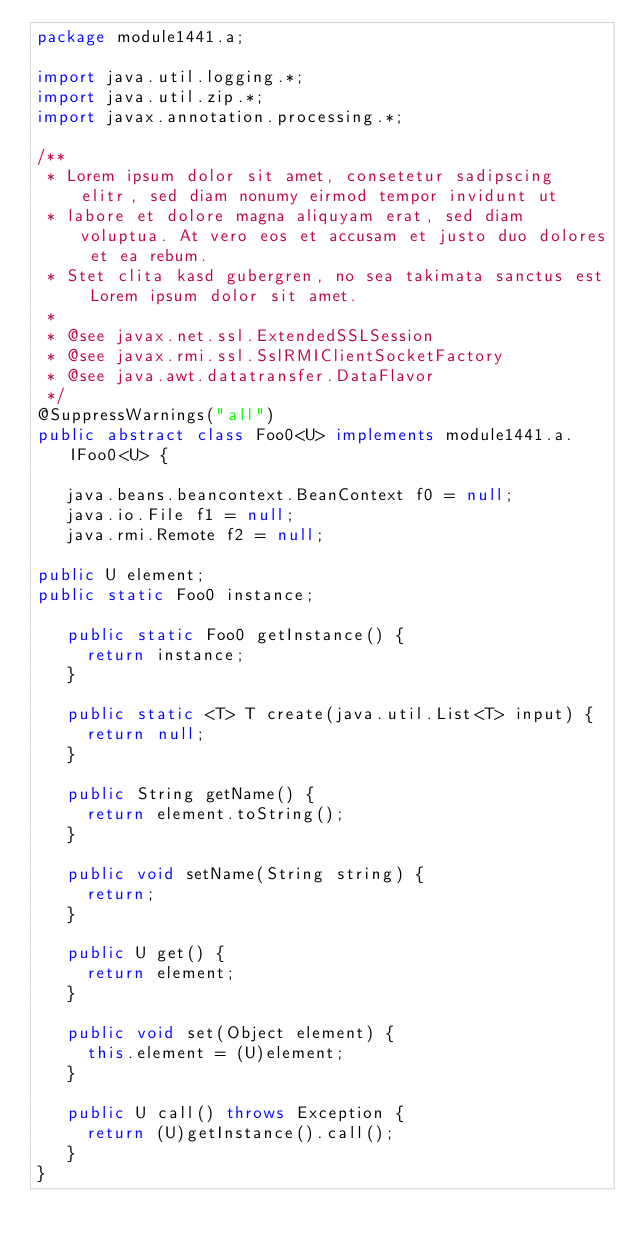Convert code to text. <code><loc_0><loc_0><loc_500><loc_500><_Java_>package module1441.a;

import java.util.logging.*;
import java.util.zip.*;
import javax.annotation.processing.*;

/**
 * Lorem ipsum dolor sit amet, consetetur sadipscing elitr, sed diam nonumy eirmod tempor invidunt ut 
 * labore et dolore magna aliquyam erat, sed diam voluptua. At vero eos et accusam et justo duo dolores et ea rebum. 
 * Stet clita kasd gubergren, no sea takimata sanctus est Lorem ipsum dolor sit amet. 
 *
 * @see javax.net.ssl.ExtendedSSLSession
 * @see javax.rmi.ssl.SslRMIClientSocketFactory
 * @see java.awt.datatransfer.DataFlavor
 */
@SuppressWarnings("all")
public abstract class Foo0<U> implements module1441.a.IFoo0<U> {

	 java.beans.beancontext.BeanContext f0 = null;
	 java.io.File f1 = null;
	 java.rmi.Remote f2 = null;

public U element;
public static Foo0 instance;

	 public static Foo0 getInstance() {
	 	 return instance;
	 }

	 public static <T> T create(java.util.List<T> input) {
	 	 return null;
	 }

	 public String getName() {
	 	 return element.toString();
	 }

	 public void setName(String string) {
	 	 return;
	 }

	 public U get() {
	 	 return element;
	 }

	 public void set(Object element) {
	 	 this.element = (U)element;
	 }

	 public U call() throws Exception {
	 	 return (U)getInstance().call();
	 }
}
</code> 